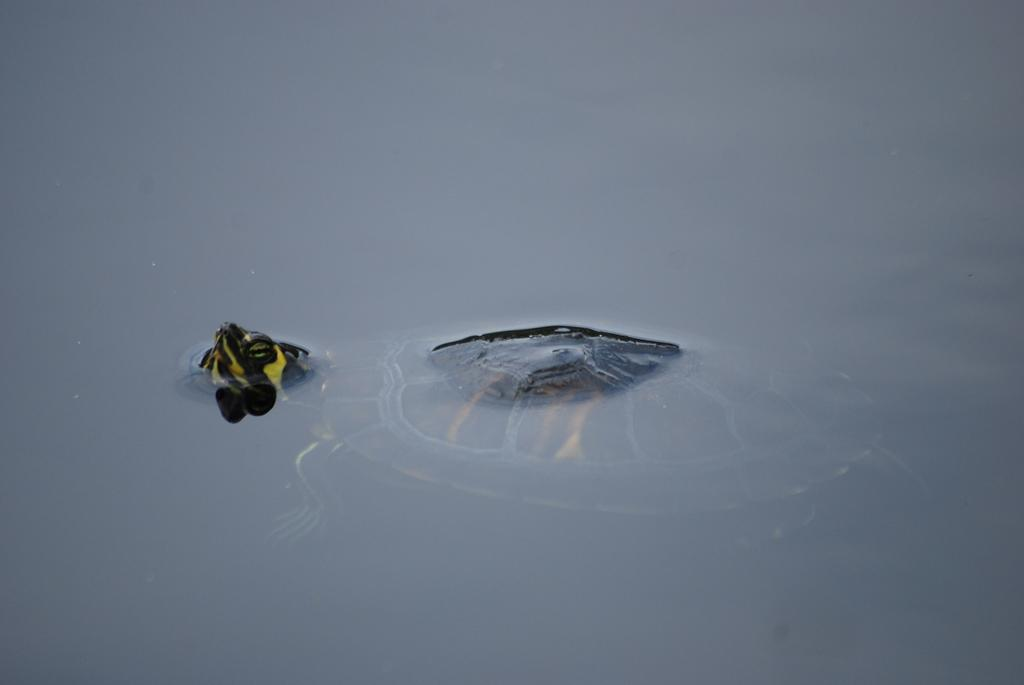What type of animal is in the image? There is a tortoise in the image. Where is the tortoise located in the image? The tortoise is in the water. What type of shade is the tortoise sitting under in the image? There is no shade present in the image; the tortoise is in the water. What type of stage is the tortoise performing on in the image? There is no stage present in the image; the tortoise is in the water. 